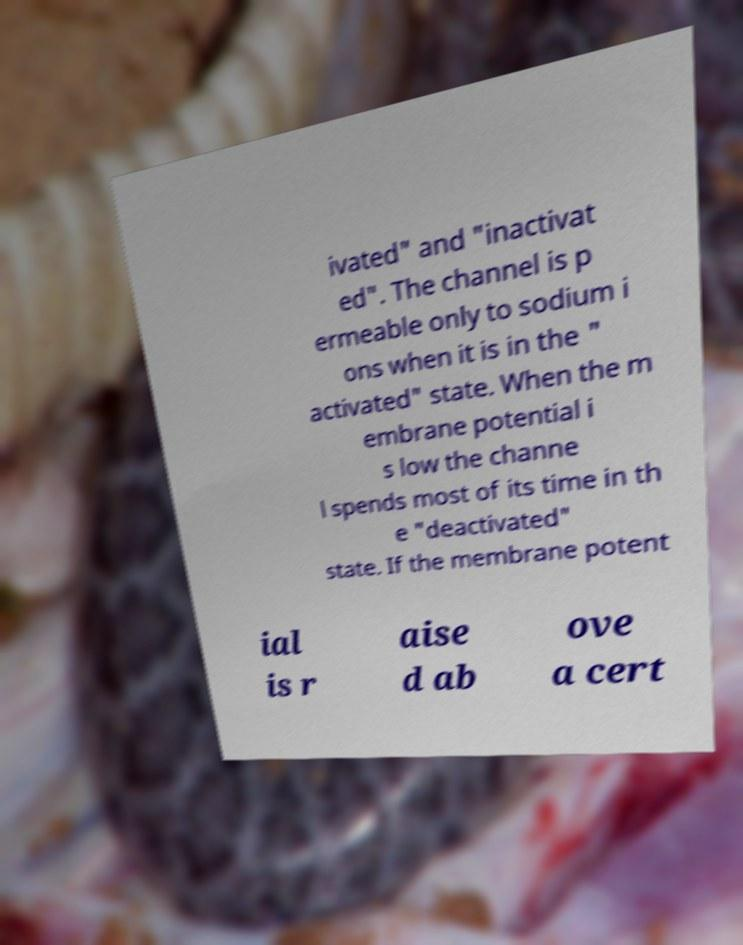For documentation purposes, I need the text within this image transcribed. Could you provide that? ivated" and "inactivat ed". The channel is p ermeable only to sodium i ons when it is in the " activated" state. When the m embrane potential i s low the channe l spends most of its time in th e "deactivated" state. If the membrane potent ial is r aise d ab ove a cert 